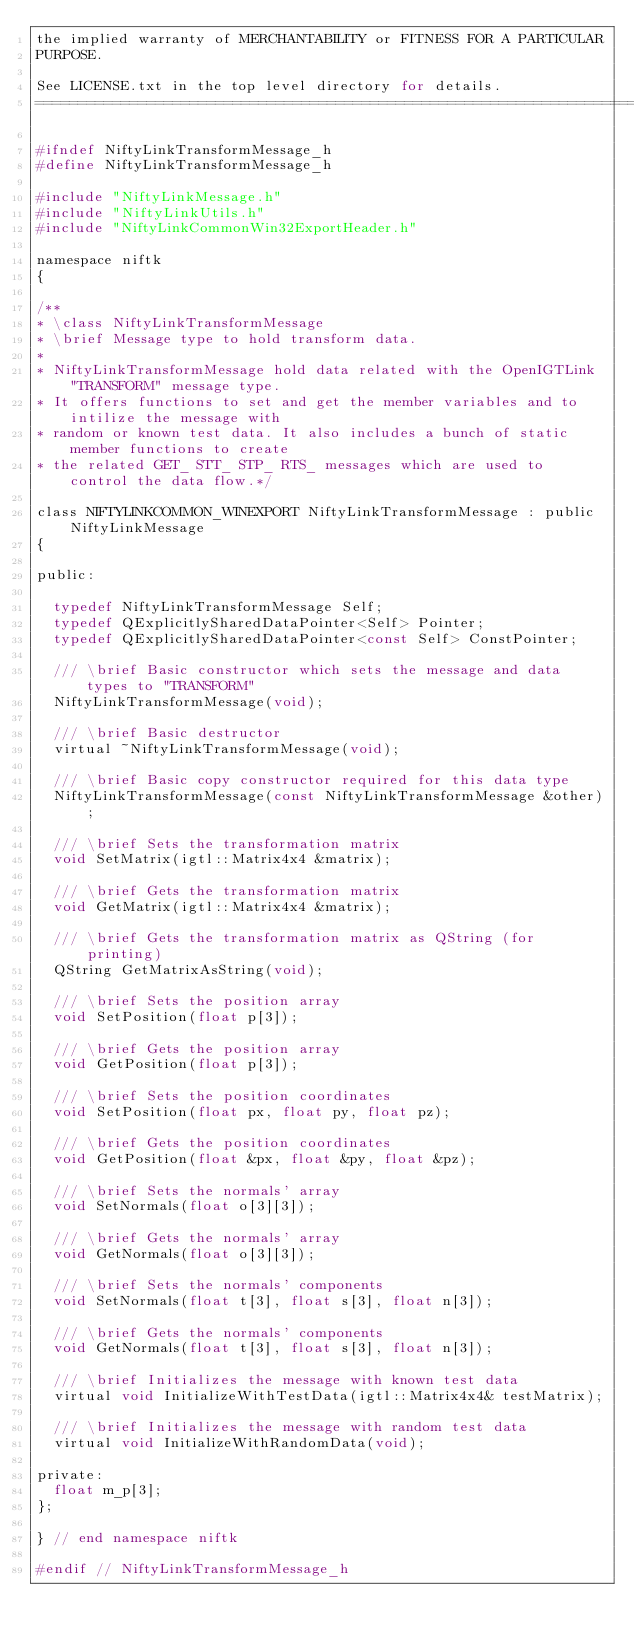Convert code to text. <code><loc_0><loc_0><loc_500><loc_500><_C_>the implied warranty of MERCHANTABILITY or FITNESS FOR A PARTICULAR
PURPOSE.

See LICENSE.txt in the top level directory for details.
=============================================================================*/

#ifndef NiftyLinkTransformMessage_h
#define NiftyLinkTransformMessage_h

#include "NiftyLinkMessage.h"
#include "NiftyLinkUtils.h"
#include "NiftyLinkCommonWin32ExportHeader.h"

namespace niftk
{

/**
* \class NiftyLinkTransformMessage
* \brief Message type to hold transform data.
*
* NiftyLinkTransformMessage hold data related with the OpenIGTLink "TRANSFORM" message type.
* It offers functions to set and get the member variables and to intilize the message with
* random or known test data. It also includes a bunch of static member functions to create
* the related GET_ STT_ STP_ RTS_ messages which are used to control the data flow.*/

class NIFTYLINKCOMMON_WINEXPORT NiftyLinkTransformMessage : public NiftyLinkMessage
{

public:

  typedef NiftyLinkTransformMessage Self;
  typedef QExplicitlySharedDataPointer<Self> Pointer;
  typedef QExplicitlySharedDataPointer<const Self> ConstPointer;

  /// \brief Basic constructor which sets the message and data types to "TRANSFORM"
  NiftyLinkTransformMessage(void);

  /// \brief Basic destructor
  virtual ~NiftyLinkTransformMessage(void);

  /// \brief Basic copy constructor required for this data type
  NiftyLinkTransformMessage(const NiftyLinkTransformMessage &other);

  /// \brief Sets the transformation matrix
  void SetMatrix(igtl::Matrix4x4 &matrix);

  /// \brief Gets the transformation matrix
  void GetMatrix(igtl::Matrix4x4 &matrix);

  /// \brief Gets the transformation matrix as QString (for printing)
  QString GetMatrixAsString(void);

  /// \brief Sets the position array
  void SetPosition(float p[3]);

  /// \brief Gets the position array
  void GetPosition(float p[3]);

  /// \brief Sets the position coordinates
  void SetPosition(float px, float py, float pz);

  /// \brief Gets the position coordinates
  void GetPosition(float &px, float &py, float &pz);

  /// \brief Sets the normals' array
  void SetNormals(float o[3][3]);

  /// \brief Gets the normals' array
  void GetNormals(float o[3][3]);

  /// \brief Sets the normals' components
  void SetNormals(float t[3], float s[3], float n[3]);

  /// \brief Gets the normals' components
  void GetNormals(float t[3], float s[3], float n[3]);

  /// \brief Initializes the message with known test data
  virtual void InitializeWithTestData(igtl::Matrix4x4& testMatrix);

  /// \brief Initializes the message with random test data
  virtual void InitializeWithRandomData(void);

private:
  float m_p[3];
};

} // end namespace niftk

#endif // NiftyLinkTransformMessage_h
</code> 